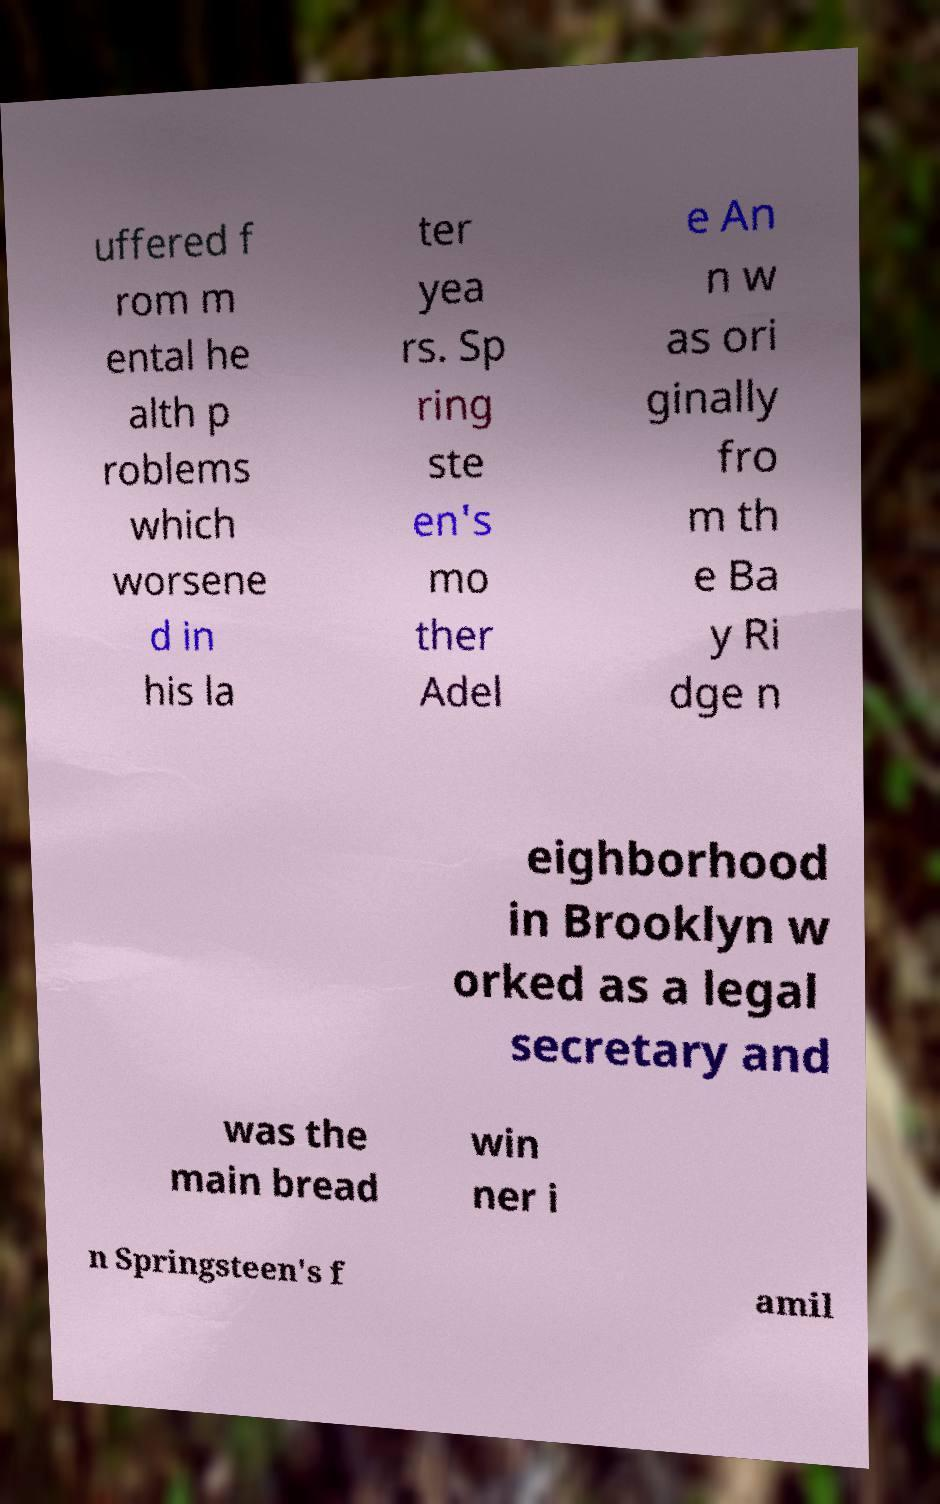I need the written content from this picture converted into text. Can you do that? uffered f rom m ental he alth p roblems which worsene d in his la ter yea rs. Sp ring ste en's mo ther Adel e An n w as ori ginally fro m th e Ba y Ri dge n eighborhood in Brooklyn w orked as a legal secretary and was the main bread win ner i n Springsteen's f amil 